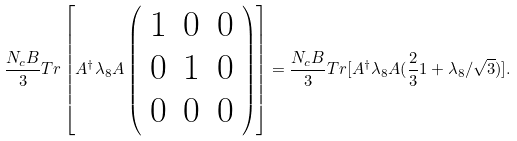Convert formula to latex. <formula><loc_0><loc_0><loc_500><loc_500>\frac { N _ { c } B } { 3 } T r \left [ A ^ { \dagger } \lambda _ { 8 } A \left ( \begin{array} { c c c } 1 & 0 & 0 \\ 0 & 1 & 0 \\ 0 & 0 & 0 \\ \end{array} \right ) \right ] = \frac { N _ { c } B } { 3 } T r [ A ^ { \dagger } \lambda _ { 8 } A ( \frac { 2 } { 3 } 1 + \lambda _ { 8 } / \sqrt { 3 } ) ] .</formula> 